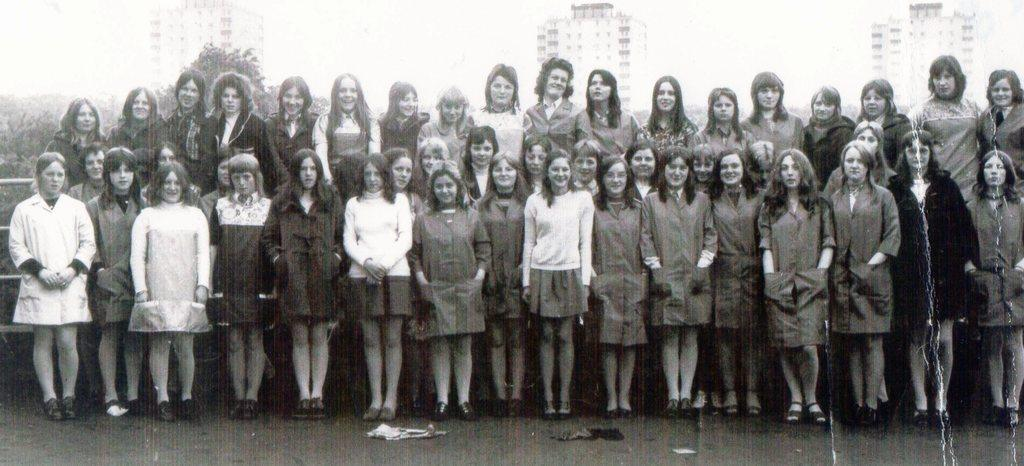What is happening in the image? There are people standing in the image. What is in front of the people? There are clothes in front of the people. What is behind the people? There is a metal fence behind the people. What can be seen in the background of the image? There are buildings, trees, and the sky visible in the background of the image. Where is the drain located in the image? There is no drain present in the image. How many brothers are standing together in the image? There is no information about brothers in the image, so we cannot determine the number of brothers present. 